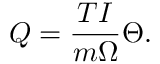Convert formula to latex. <formula><loc_0><loc_0><loc_500><loc_500>Q = \frac { T I } { m \Omega } \Theta .</formula> 